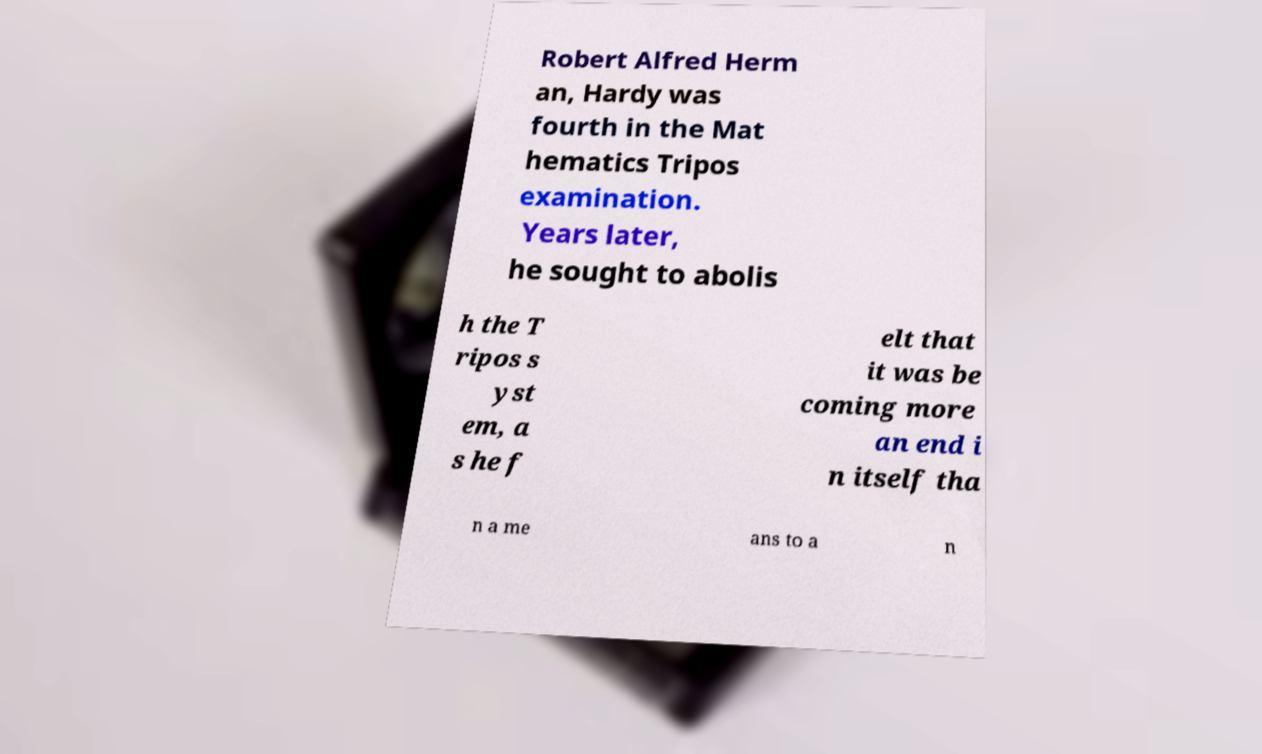Please identify and transcribe the text found in this image. Robert Alfred Herm an, Hardy was fourth in the Mat hematics Tripos examination. Years later, he sought to abolis h the T ripos s yst em, a s he f elt that it was be coming more an end i n itself tha n a me ans to a n 